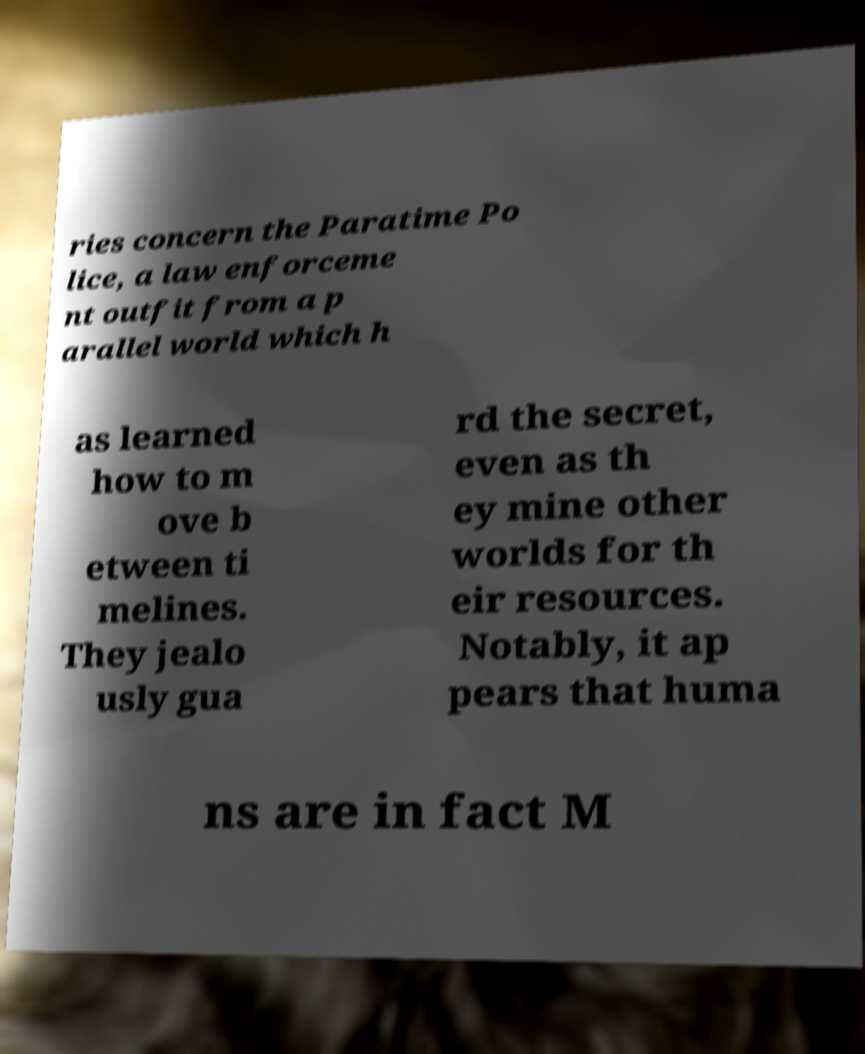For documentation purposes, I need the text within this image transcribed. Could you provide that? ries concern the Paratime Po lice, a law enforceme nt outfit from a p arallel world which h as learned how to m ove b etween ti melines. They jealo usly gua rd the secret, even as th ey mine other worlds for th eir resources. Notably, it ap pears that huma ns are in fact M 